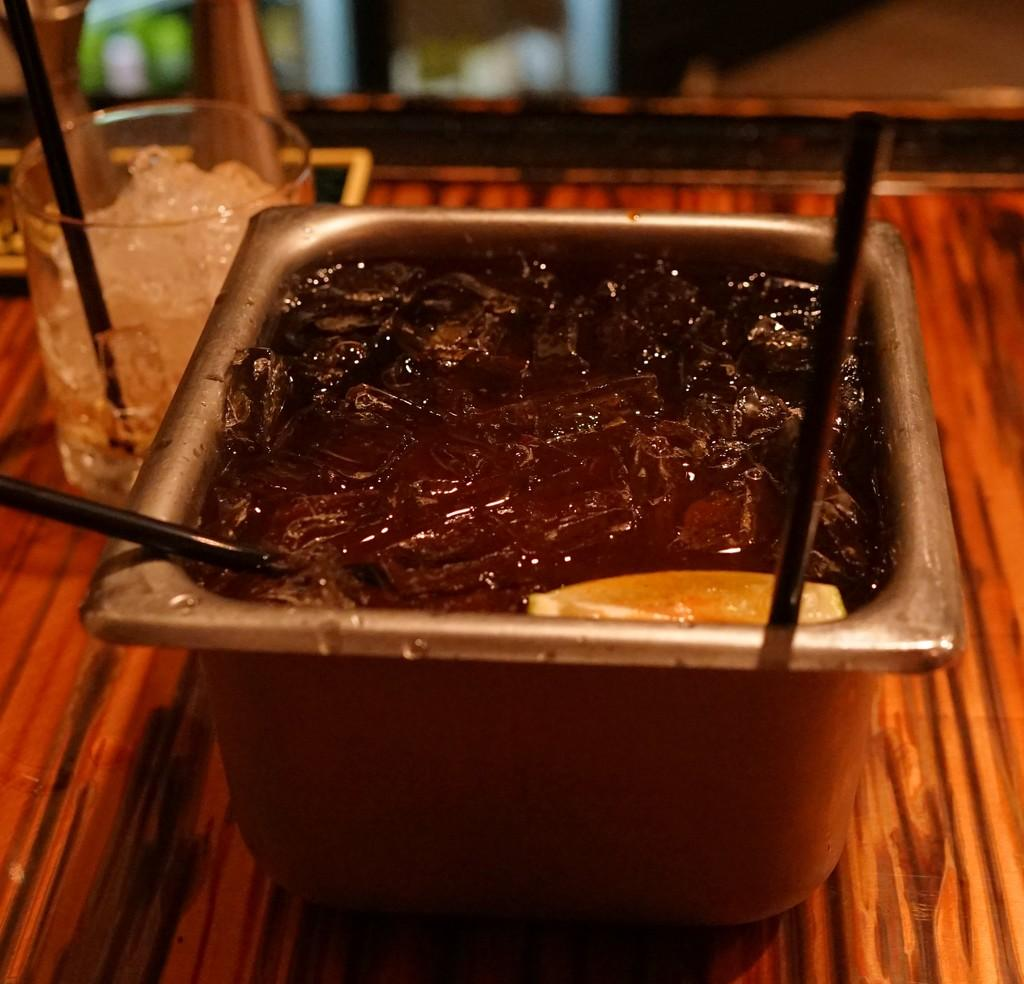What is the main piece of furniture in the image? There is a table in the image. What is on the table? There is a container on the table. What is inside the container? The container has ice and water in it. What is used to hold a liquid in the image? There is a glass in the image. What is in the glass? There is ice in the glass. How many horses can be seen playing with kittens in the image? There are no horses or kittens present in the image. What type of current is flowing through the ice in the glass? There is no current present in the image; it is a still image. 